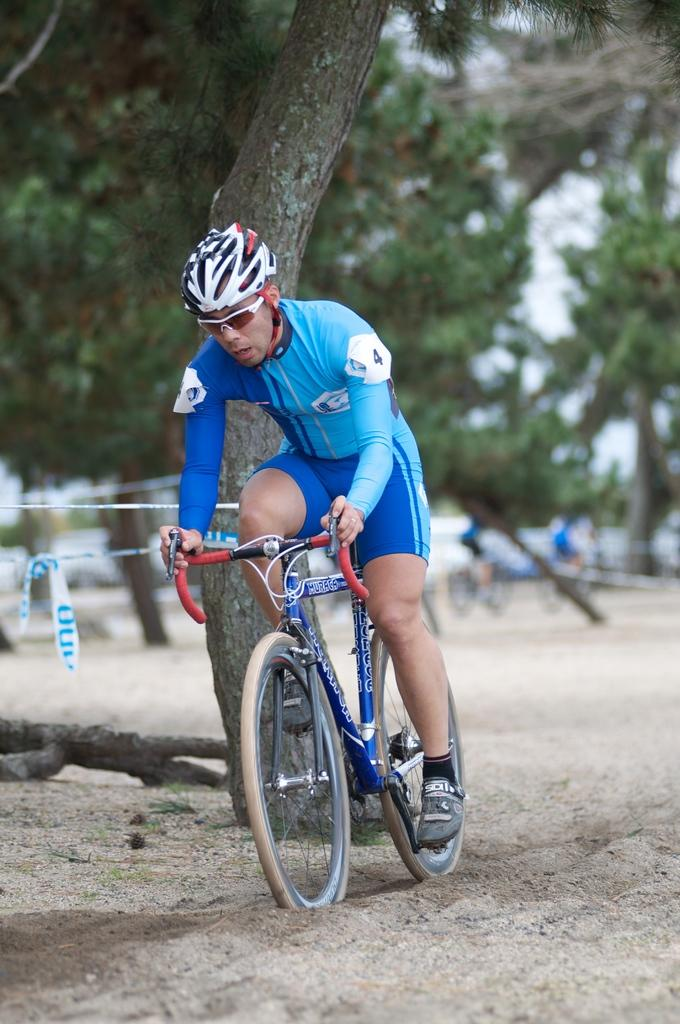Who is the main subject in the image? There is a man in the image. What is the man doing in the image? The man is riding a bicycle. What can be seen in the background of the image? There are trees in the background of the image. What type of cracker is the man holding while riding the bicycle in the image? There is no cracker present in the image; the man is riding a bicycle. Can you tell me how many aunts are visible in the image? There are no aunts present in the image; it features a man riding a bicycle. 